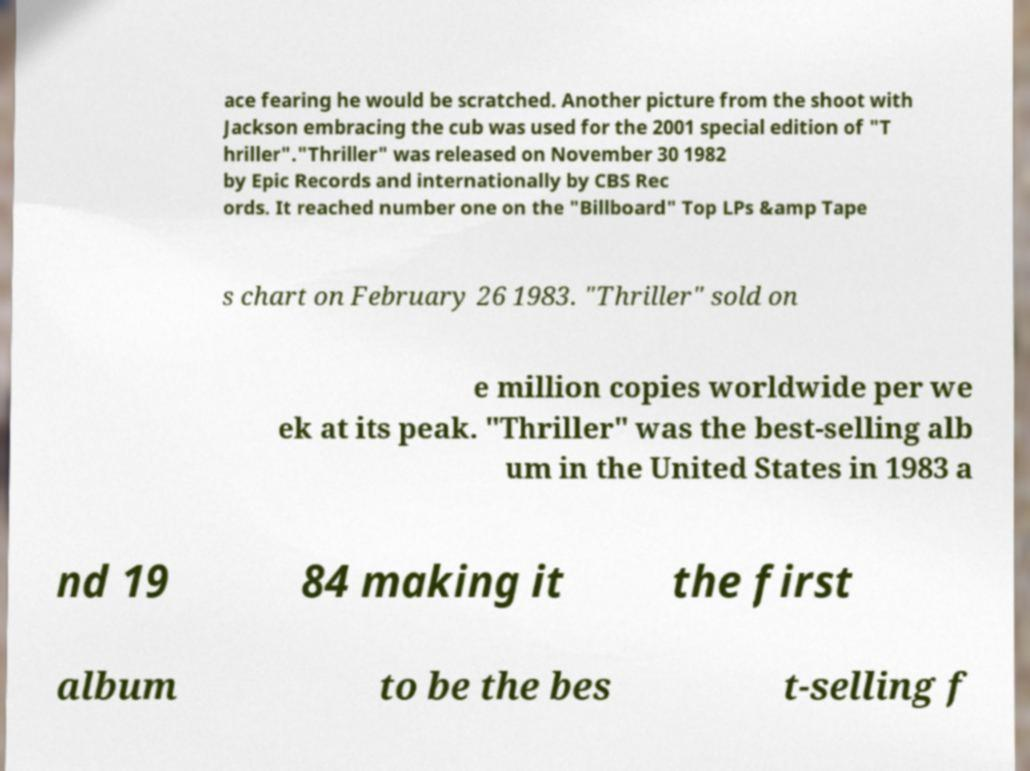I need the written content from this picture converted into text. Can you do that? ace fearing he would be scratched. Another picture from the shoot with Jackson embracing the cub was used for the 2001 special edition of "T hriller"."Thriller" was released on November 30 1982 by Epic Records and internationally by CBS Rec ords. It reached number one on the "Billboard" Top LPs &amp Tape s chart on February 26 1983. "Thriller" sold on e million copies worldwide per we ek at its peak. "Thriller" was the best-selling alb um in the United States in 1983 a nd 19 84 making it the first album to be the bes t-selling f 